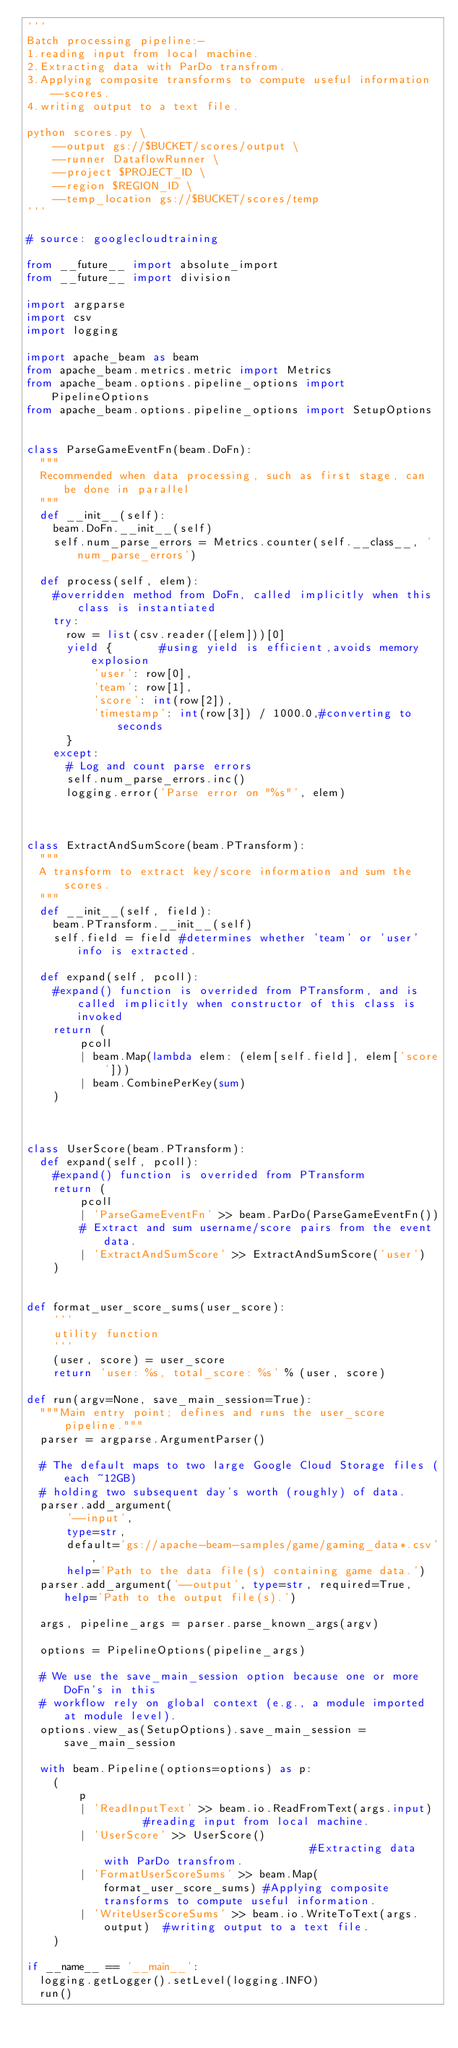<code> <loc_0><loc_0><loc_500><loc_500><_Python_>'''
Batch processing pipeline:-
1.reading input from local machine.
2.Extracting data with ParDo transfrom.
3.Applying composite transforms to compute useful information--scores.
4.writing output to a text file.

python scores.py \
    --output gs://$BUCKET/scores/output \
    --runner DataflowRunner \
    --project $PROJECT_ID \
    --region $REGION_ID \
    --temp_location gs://$BUCKET/scores/temp
'''

# source: googlecloudtraining

from __future__ import absolute_import
from __future__ import division

import argparse
import csv
import logging

import apache_beam as beam
from apache_beam.metrics.metric import Metrics
from apache_beam.options.pipeline_options import PipelineOptions
from apache_beam.options.pipeline_options import SetupOptions


class ParseGameEventFn(beam.DoFn):
  """
  Recommended when data processing, such as first stage, can be done in parallel
  """
  def __init__(self):
    beam.DoFn.__init__(self)
    self.num_parse_errors = Metrics.counter(self.__class__, 'num_parse_errors')

  def process(self, elem):
    #overridden method from DoFn, called implicitly when this class is instantiated
    try:
      row = list(csv.reader([elem]))[0]
      yield {       #using yield is efficient,avoids memory explosion
          'user': row[0],
          'team': row[1],
          'score': int(row[2]),
          'timestamp': int(row[3]) / 1000.0,#converting to seconds
      }
    except:
      # Log and count parse errors
      self.num_parse_errors.inc()
      logging.error('Parse error on "%s"', elem)



class ExtractAndSumScore(beam.PTransform):
  """
  A transform to extract key/score information and sum the scores.
  """
  def __init__(self, field):
    beam.PTransform.__init__(self)
    self.field = field #determines whether 'team' or 'user' info is extracted.

  def expand(self, pcoll):
    #expand() function is overrided from PTransform, and is called implicitly when constructor of this class is invoked
    return (
        pcoll
        | beam.Map(lambda elem: (elem[self.field], elem['score']))
        | beam.CombinePerKey(sum)
    )



class UserScore(beam.PTransform):
  def expand(self, pcoll):
    #expand() function is overrided from PTransform
    return (
        pcoll
        | 'ParseGameEventFn' >> beam.ParDo(ParseGameEventFn())
        # Extract and sum username/score pairs from the event data.
        | 'ExtractAndSumScore' >> ExtractAndSumScore('user')
    )


def format_user_score_sums(user_score):
    '''
    utility function
    '''
    (user, score) = user_score
    return 'user: %s, total_score: %s' % (user, score)

def run(argv=None, save_main_session=True):
  """Main entry point; defines and runs the user_score pipeline."""
  parser = argparse.ArgumentParser()

  # The default maps to two large Google Cloud Storage files (each ~12GB)
  # holding two subsequent day's worth (roughly) of data.
  parser.add_argument(
      '--input',
      type=str,
      default='gs://apache-beam-samples/game/gaming_data*.csv',
      help='Path to the data file(s) containing game data.')
  parser.add_argument('--output', type=str, required=True, help='Path to the output file(s).')

  args, pipeline_args = parser.parse_known_args(argv)

  options = PipelineOptions(pipeline_args)

  # We use the save_main_session option because one or more DoFn's in this
  # workflow rely on global context (e.g., a module imported at module level).
  options.view_as(SetupOptions).save_main_session = save_main_session

  with beam.Pipeline(options=options) as p:
    (  
        p
        | 'ReadInputText' >> beam.io.ReadFromText(args.input)       #reading input from local machine.
        | 'UserScore' >> UserScore()                                #Extracting data with ParDo transfrom.
        | 'FormatUserScoreSums' >> beam.Map(format_user_score_sums) #Applying composite transforms to compute useful information.
        | 'WriteUserScoreSums' >> beam.io.WriteToText(args.output)  #writing output to a text file.
    )

if __name__ == '__main__':
  logging.getLogger().setLevel(logging.INFO)
  run()
</code> 